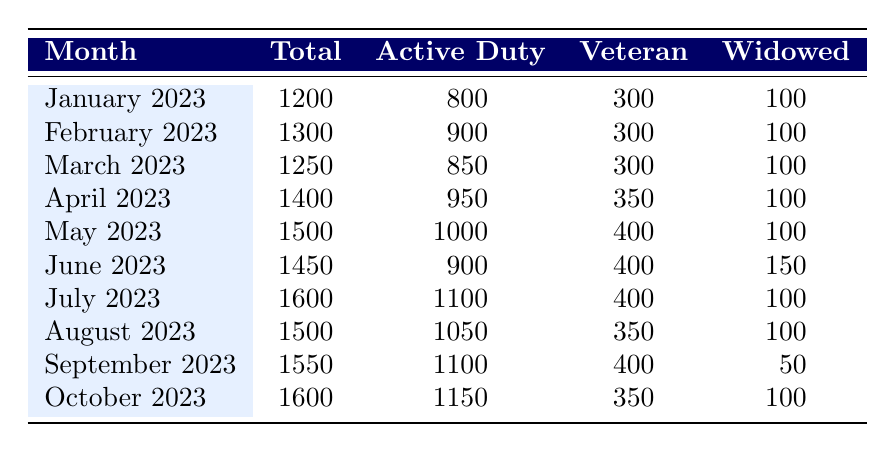What was the total number of participants in May 2023? From the row corresponding to May 2023, I can see that the total number of participants is listed as 1500.
Answer: 1500 What percentage of participants in February 2023 were Active Duty spouses? The total number of participants in February 2023 is 1300, with Active Duty spouses numbering 900. To find the percentage, I calculate (900/1300) * 100 = 69.23%.
Answer: 69.23% In which month did the number of Veteran spouses reach its peak? Looking at the table, April 2023 has the highest number of Veteran spouses at 350, while other months have either 300 or 400. So the peak is in April.
Answer: April 2023 How many more Active Duty spouses participated in July 2023 compared to January 2023? In July 2023, there were 1100 Active Duty spouses, and in January 2023, there were 800. The difference is 1100 - 800 = 300.
Answer: 300 Was there a decline in the number of Total Participants from June to July 2023? The total number of participants in June 2023 was 1450, and in July 2023, it was 1600. Since 1600 is greater than 1450, there was no decline.
Answer: No What is the average number of Widowed spouses participating in the program from January to October 2023? The total number of Widowed spouses from January to October 2023 is 100 + 100 + 100 + 100 + 100 + 150 + 100 + 100 + 50 + 100 = 1150. There are 10 months, so the average is 1150/10 = 115.
Answer: 115 Did the participation of Active Duty spouses in August 2023 exceed that of Veteran spouses in the same month? In August 2023, the number of Active Duty spouses was 1050, while the number of Veteran spouses was 350. Since 1050 is greater than 350, the statement is true.
Answer: Yes Which month saw the largest total number of participants? The months are listed with their total participants, and both July 2023 and October 2023 have 1600 participants, which is the largest amount.
Answer: July 2023 and October 2023 What was the total increase in participants from January to October 2023? The total participants in January 2023 were 1200 and in October 2023 were 1600. To find the increase, I subtract January’s total from October’s total: 1600 - 1200 = 400.
Answer: 400 